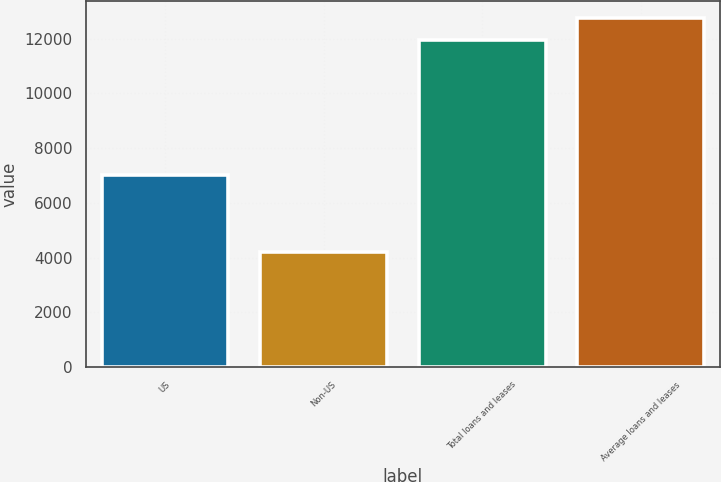<chart> <loc_0><loc_0><loc_500><loc_500><bar_chart><fcel>US<fcel>Non-US<fcel>Total loans and leases<fcel>Average loans and leases<nl><fcel>7001<fcel>4192<fcel>11957<fcel>12747.2<nl></chart> 